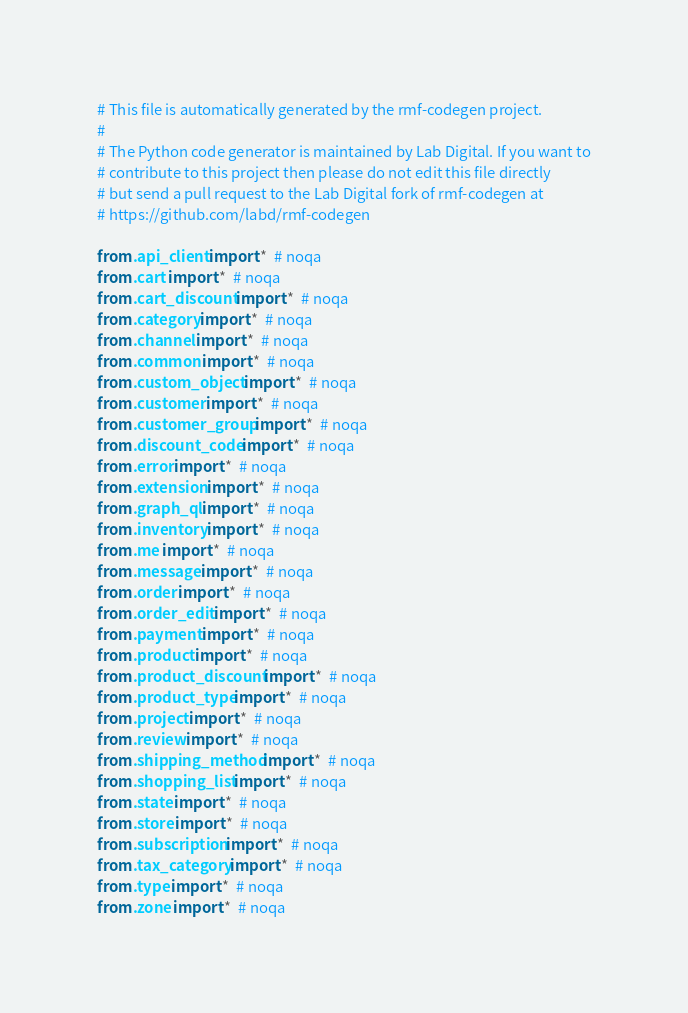<code> <loc_0><loc_0><loc_500><loc_500><_Python_># This file is automatically generated by the rmf-codegen project.
#
# The Python code generator is maintained by Lab Digital. If you want to
# contribute to this project then please do not edit this file directly
# but send a pull request to the Lab Digital fork of rmf-codegen at
# https://github.com/labd/rmf-codegen

from .api_client import *  # noqa
from .cart import *  # noqa
from .cart_discount import *  # noqa
from .category import *  # noqa
from .channel import *  # noqa
from .common import *  # noqa
from .custom_object import *  # noqa
from .customer import *  # noqa
from .customer_group import *  # noqa
from .discount_code import *  # noqa
from .error import *  # noqa
from .extension import *  # noqa
from .graph_ql import *  # noqa
from .inventory import *  # noqa
from .me import *  # noqa
from .message import *  # noqa
from .order import *  # noqa
from .order_edit import *  # noqa
from .payment import *  # noqa
from .product import *  # noqa
from .product_discount import *  # noqa
from .product_type import *  # noqa
from .project import *  # noqa
from .review import *  # noqa
from .shipping_method import *  # noqa
from .shopping_list import *  # noqa
from .state import *  # noqa
from .store import *  # noqa
from .subscription import *  # noqa
from .tax_category import *  # noqa
from .type import *  # noqa
from .zone import *  # noqa
</code> 